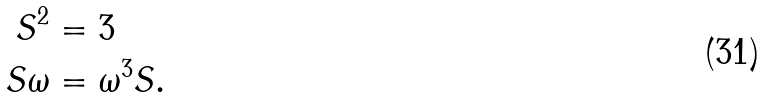<formula> <loc_0><loc_0><loc_500><loc_500>S ^ { 2 } & = 3 \\ S \omega & = \omega ^ { 3 } S .</formula> 